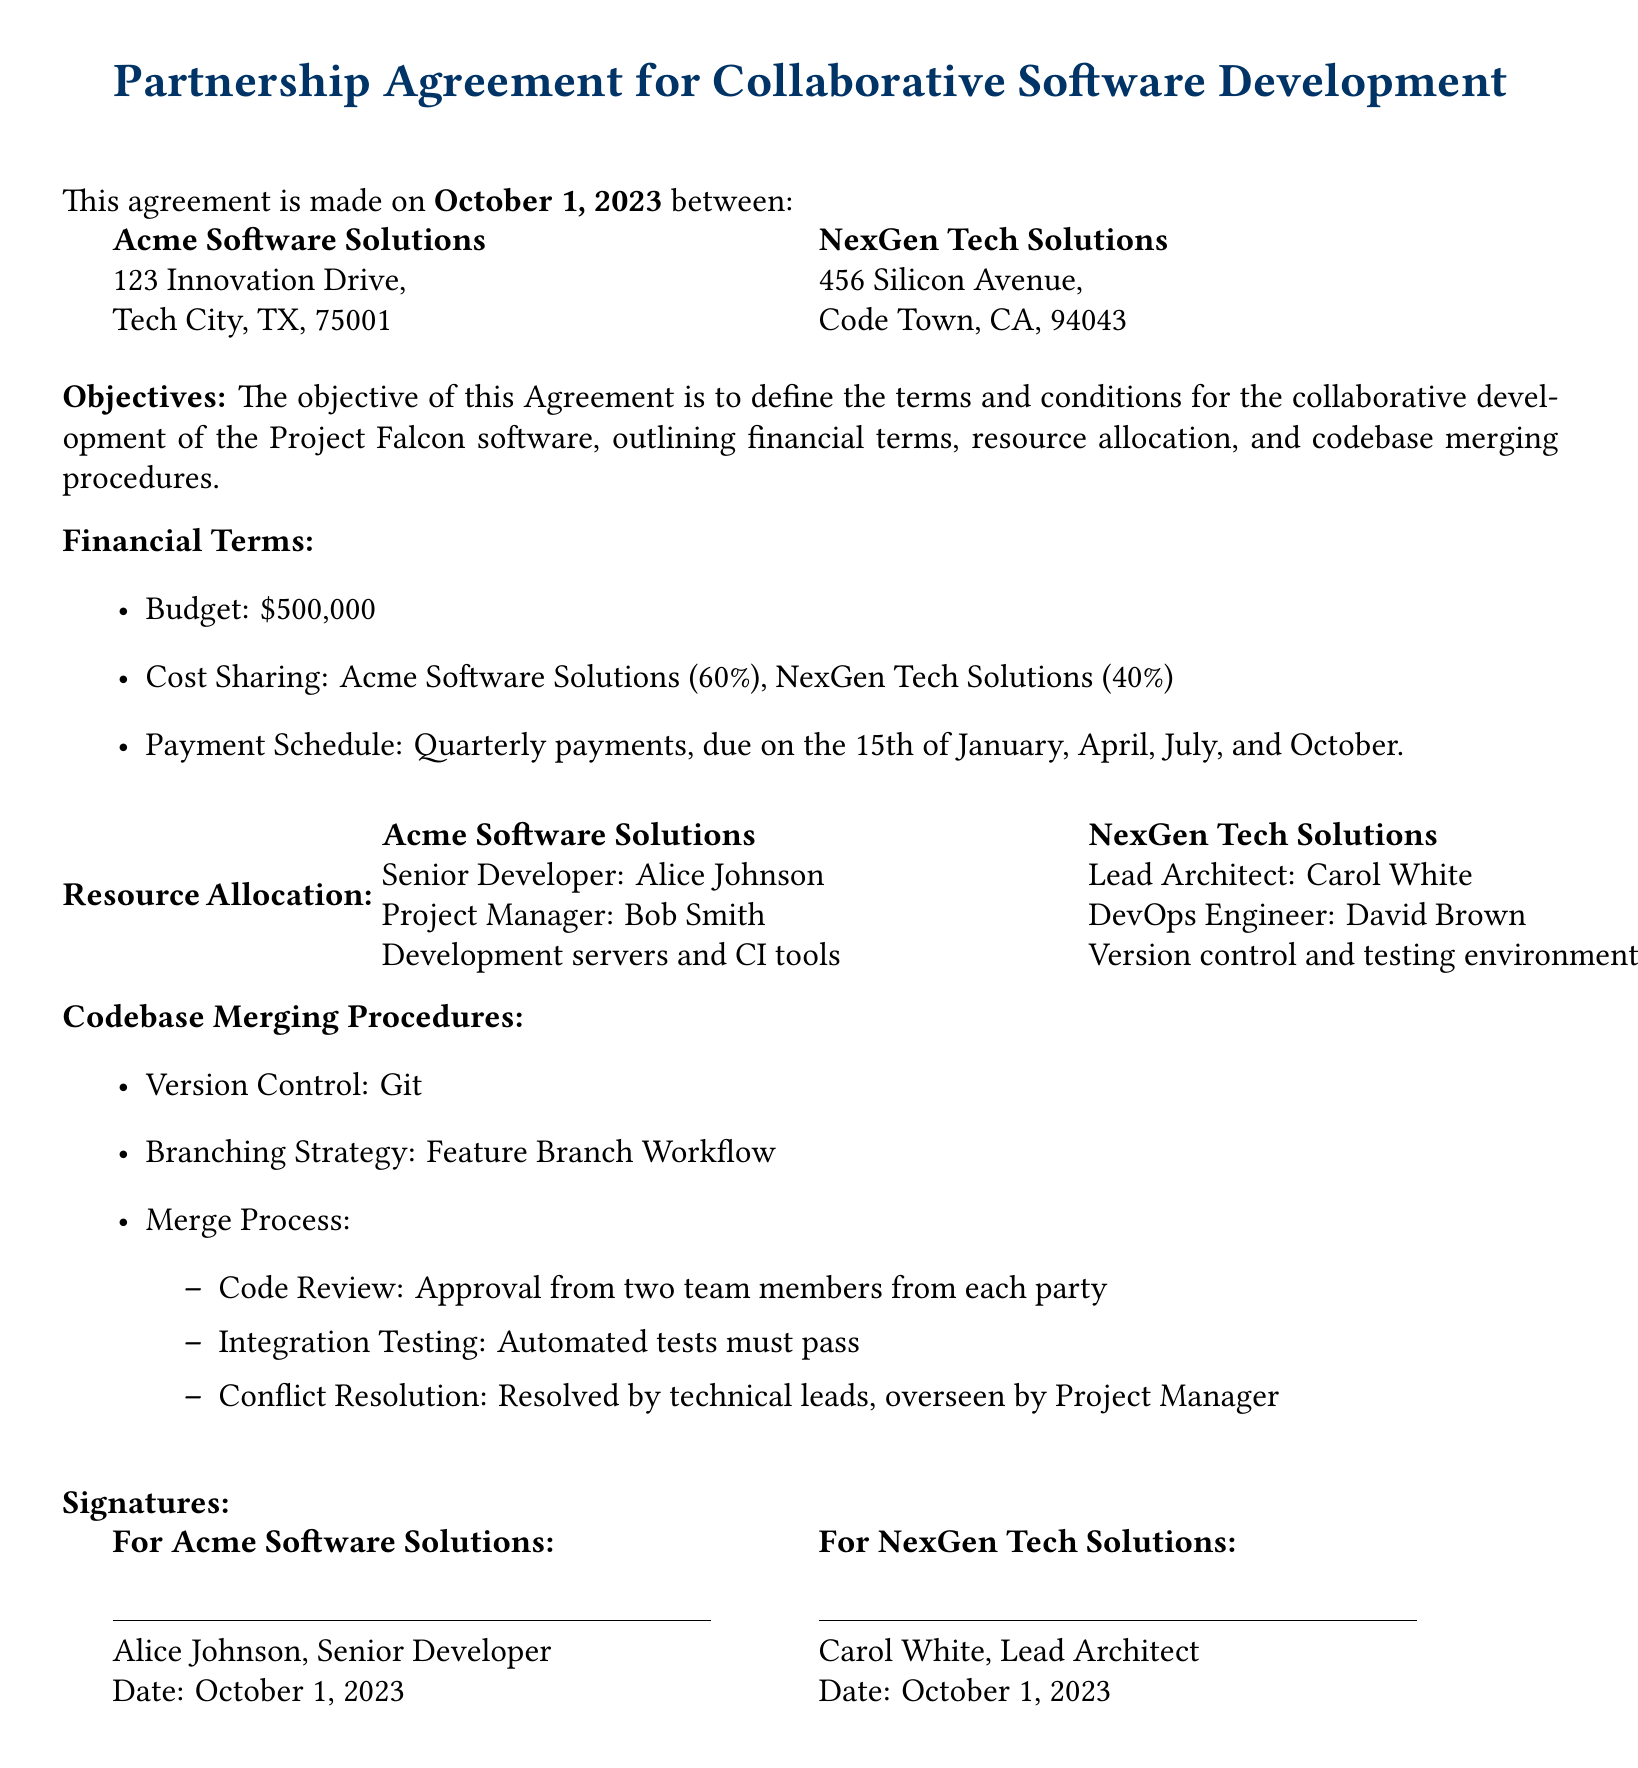What is the date of the agreement? The date of the agreement is specified at the beginning of the document.
Answer: October 1, 2023 Who is the Senior Developer at Acme Software Solutions? The document lists the Senior Developer for Acme Software Solutions in the Resource Allocation section.
Answer: Alice Johnson What percentage of the budget does NexGen Tech Solutions cover? The cost sharing section specifies the percentage for each party.
Answer: 40% What is the total budget for the project? The total budget is stated in the Financial Terms section of the document.
Answer: $500,000 What is the name of the DevOps Engineer at NexGen Tech Solutions? The document provides the names of the personnel assigned in the Resource Allocation section.
Answer: David Brown How often are payments scheduled to be made? The payment schedule outlines when payments are due in the document.
Answer: Quarterly What is the branching strategy mentioned in the Codebase Merging Procedures? The Codebase Merging Procedures section describes the strategy used for version control.
Answer: Feature Branch Workflow Who needs to approve the code review? The document specifies the number of team members required for the approval process in the merge process.
Answer: Two team members from each party What role does Bob Smith hold at Acme Software Solutions? Bob Smith's position is listed in the Resource Allocation section.
Answer: Project Manager 